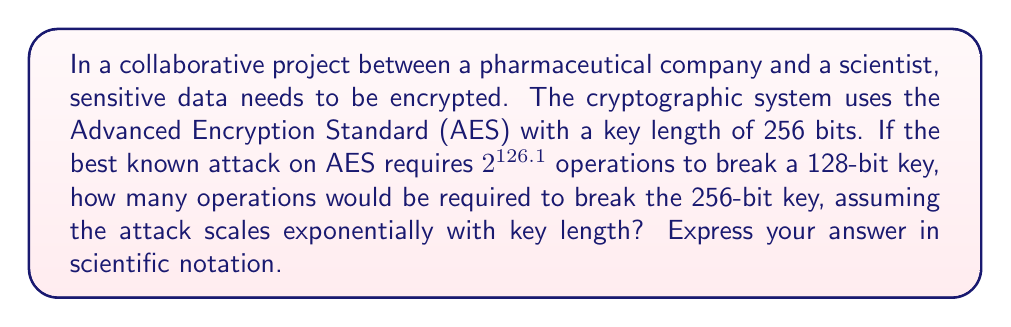Teach me how to tackle this problem. To solve this problem, we'll follow these steps:

1) First, we need to understand the relationship between key length and attack complexity:
   - For 128-bit key: $2^{126.1}$ operations
   - For 256-bit key: unknown (let's call it $x$)

2) The attack complexity scales exponentially with key length. This means we can set up a proportion:

   $$\frac{2^{126.1}}{2^{128}} = \frac{x}{2^{256}}$$

3) Simplify the left side of the equation:
   $$2^{-1.9} = \frac{x}{2^{256}}$$

4) Multiply both sides by $2^{256}$:
   $$x = 2^{-1.9} \cdot 2^{256} = 2^{254.1}$$

5) Now we have the number of operations, but we need to express it in scientific notation.

6) To convert $2^{254.1}$ to scientific notation:
   $$2^{254.1} = 10^{254.1 \cdot \log_{10}2} \approx 10^{76.5}$$

Therefore, approximately $10^{76.5}$ operations would be required to break the 256-bit key.
Answer: $10^{76.5}$ operations 